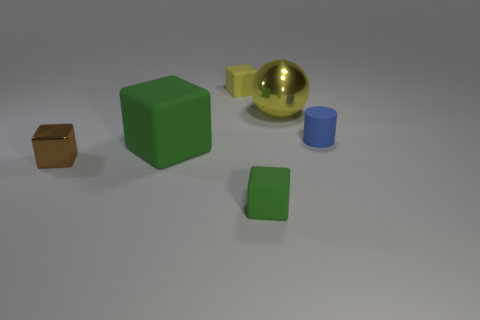Are there any other things that have the same shape as the small blue rubber object?
Make the answer very short. No. There is a small block that is behind the yellow shiny ball behind the brown cube; what is its material?
Your answer should be very brief. Rubber. What is the size of the brown cube?
Give a very brief answer. Small. What number of yellow metallic things are the same size as the cylinder?
Provide a succinct answer. 0. How many small rubber things have the same shape as the small shiny object?
Make the answer very short. 2. Are there the same number of big metal objects that are on the left side of the big yellow ball and blue objects?
Keep it short and to the point. No. There is a blue rubber object that is the same size as the metallic block; what shape is it?
Keep it short and to the point. Cylinder. Are there any green matte things that have the same shape as the brown thing?
Your answer should be very brief. Yes. Are there any yellow rubber cubes behind the green block that is on the left side of the tiny object behind the large yellow metal ball?
Offer a very short reply. Yes. Are there more yellow cubes that are to the left of the small blue matte cylinder than big green objects in front of the small green block?
Give a very brief answer. Yes. 